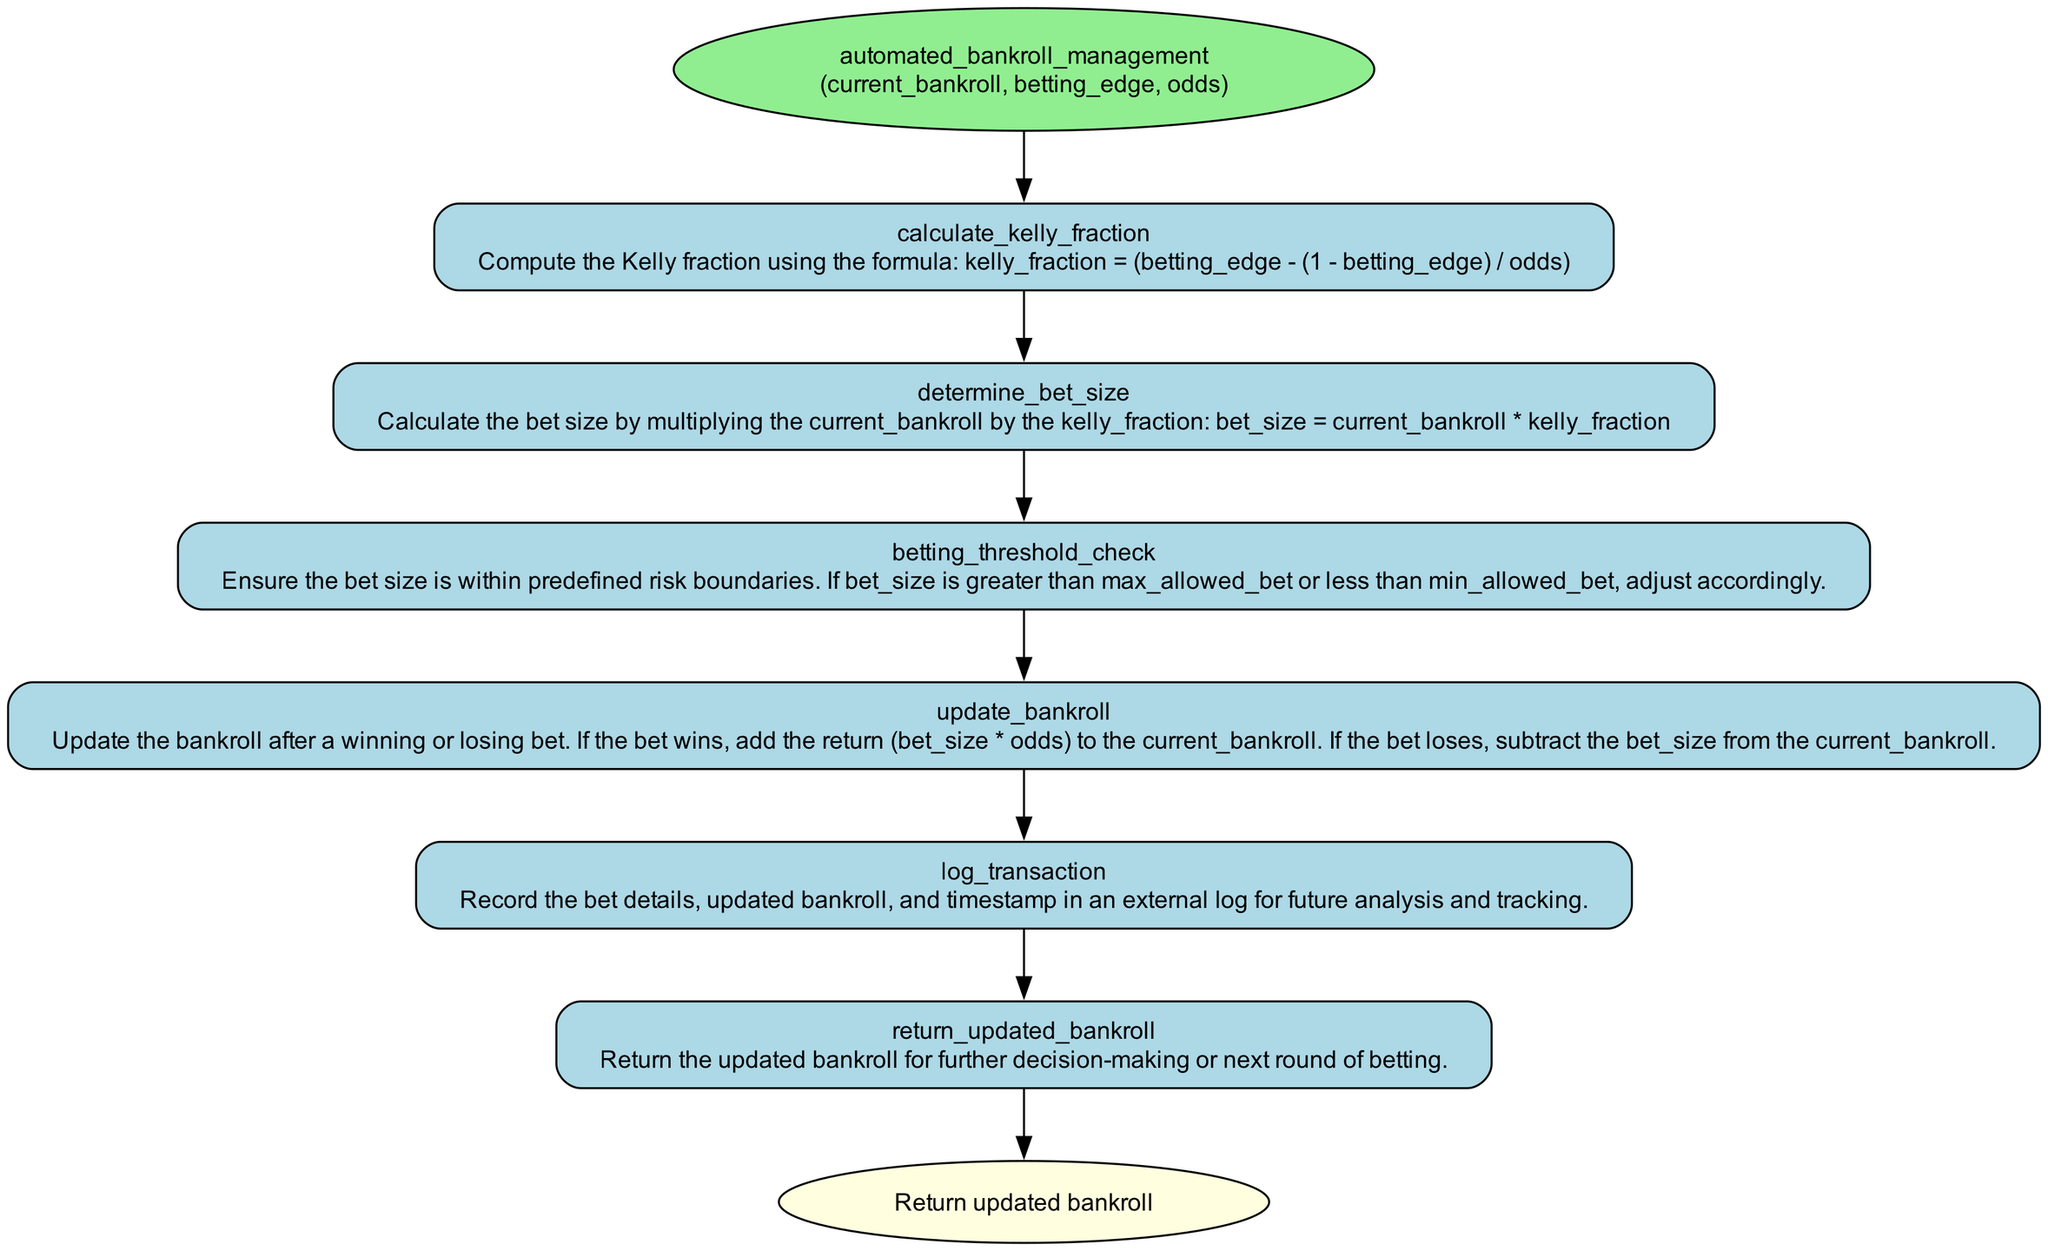what is the first step in the function? The first step in the function is named "calculate_kelly_fraction" and its purpose is to compute the Kelly fraction.
Answer: calculate kelly fraction how many steps are there in total? The diagram consists of five steps, from calculating the Kelly fraction to logging the transaction.
Answer: five what action is taken after determining the bet size? After determining the bet size, the next action is to check the betting threshold.
Answer: check betting threshold which step handles bankroll updates? The step that handles bankroll updates is called "update_bankroll," which modifies the bankroll based on winning or losing bets.
Answer: update bankroll what is returned at the end of the function? The function returns the updated bankroll for further decision-making.
Answer: updated bankroll what is computed in the fourth step? The fourth step computes changes to the bankroll based on the outcome of the bet (win or loss).
Answer: bankroll changes how does the function react if the bet size is outside risk boundaries? If the bet size is outside the predefined risk boundaries, it is adjusted accordingly during the threshold check.
Answer: adjusted accordingly what is the main purpose of logging transactions? The main purpose of logging transactions is to record bet details, updated bankroll, and timestamp for future analysis and tracking.
Answer: future analysis and tracking 